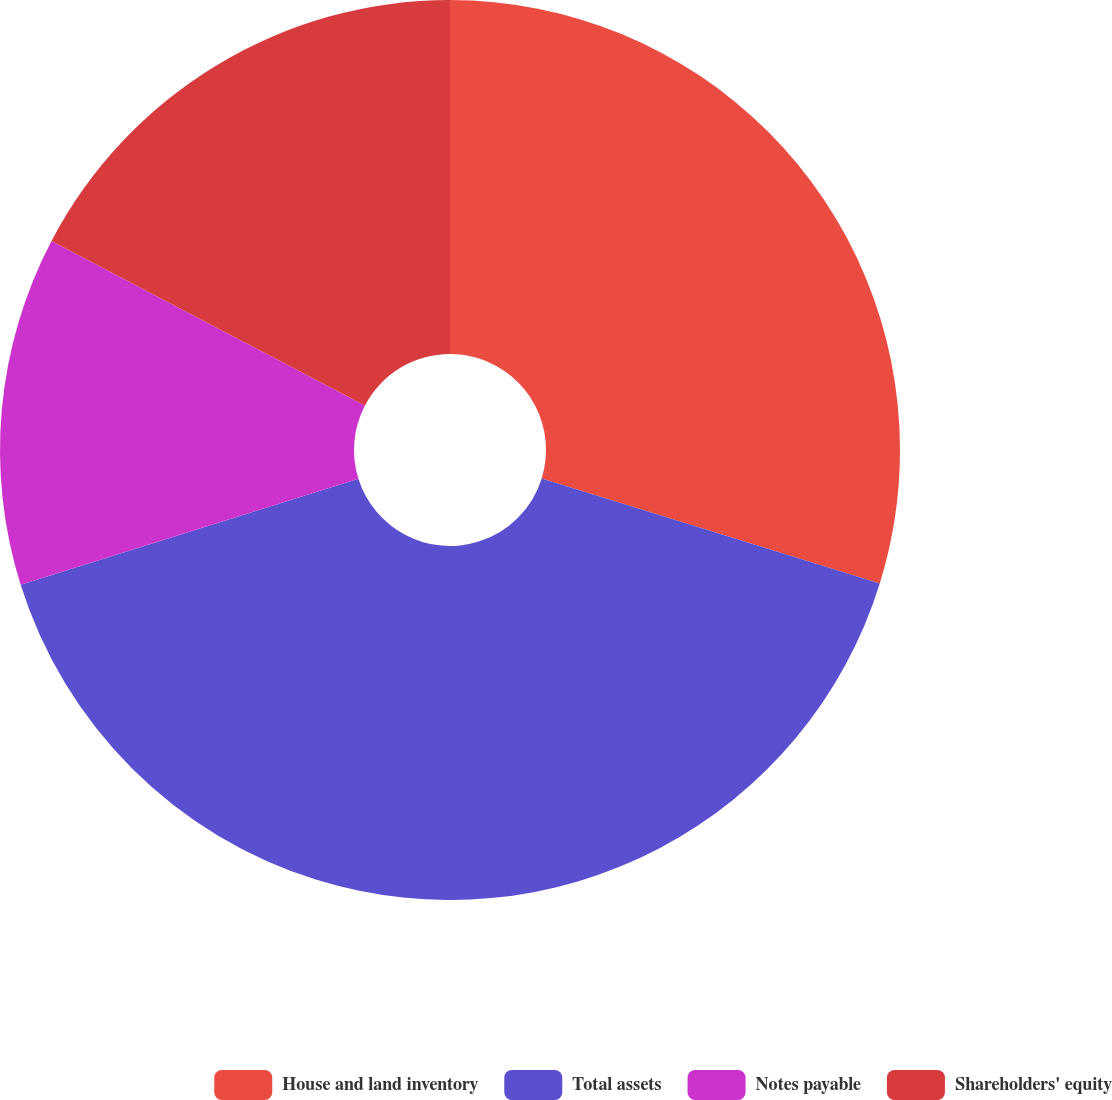Convert chart to OTSL. <chart><loc_0><loc_0><loc_500><loc_500><pie_chart><fcel>House and land inventory<fcel>Total assets<fcel>Notes payable<fcel>Shareholders' equity<nl><fcel>29.79%<fcel>40.37%<fcel>12.53%<fcel>17.31%<nl></chart> 